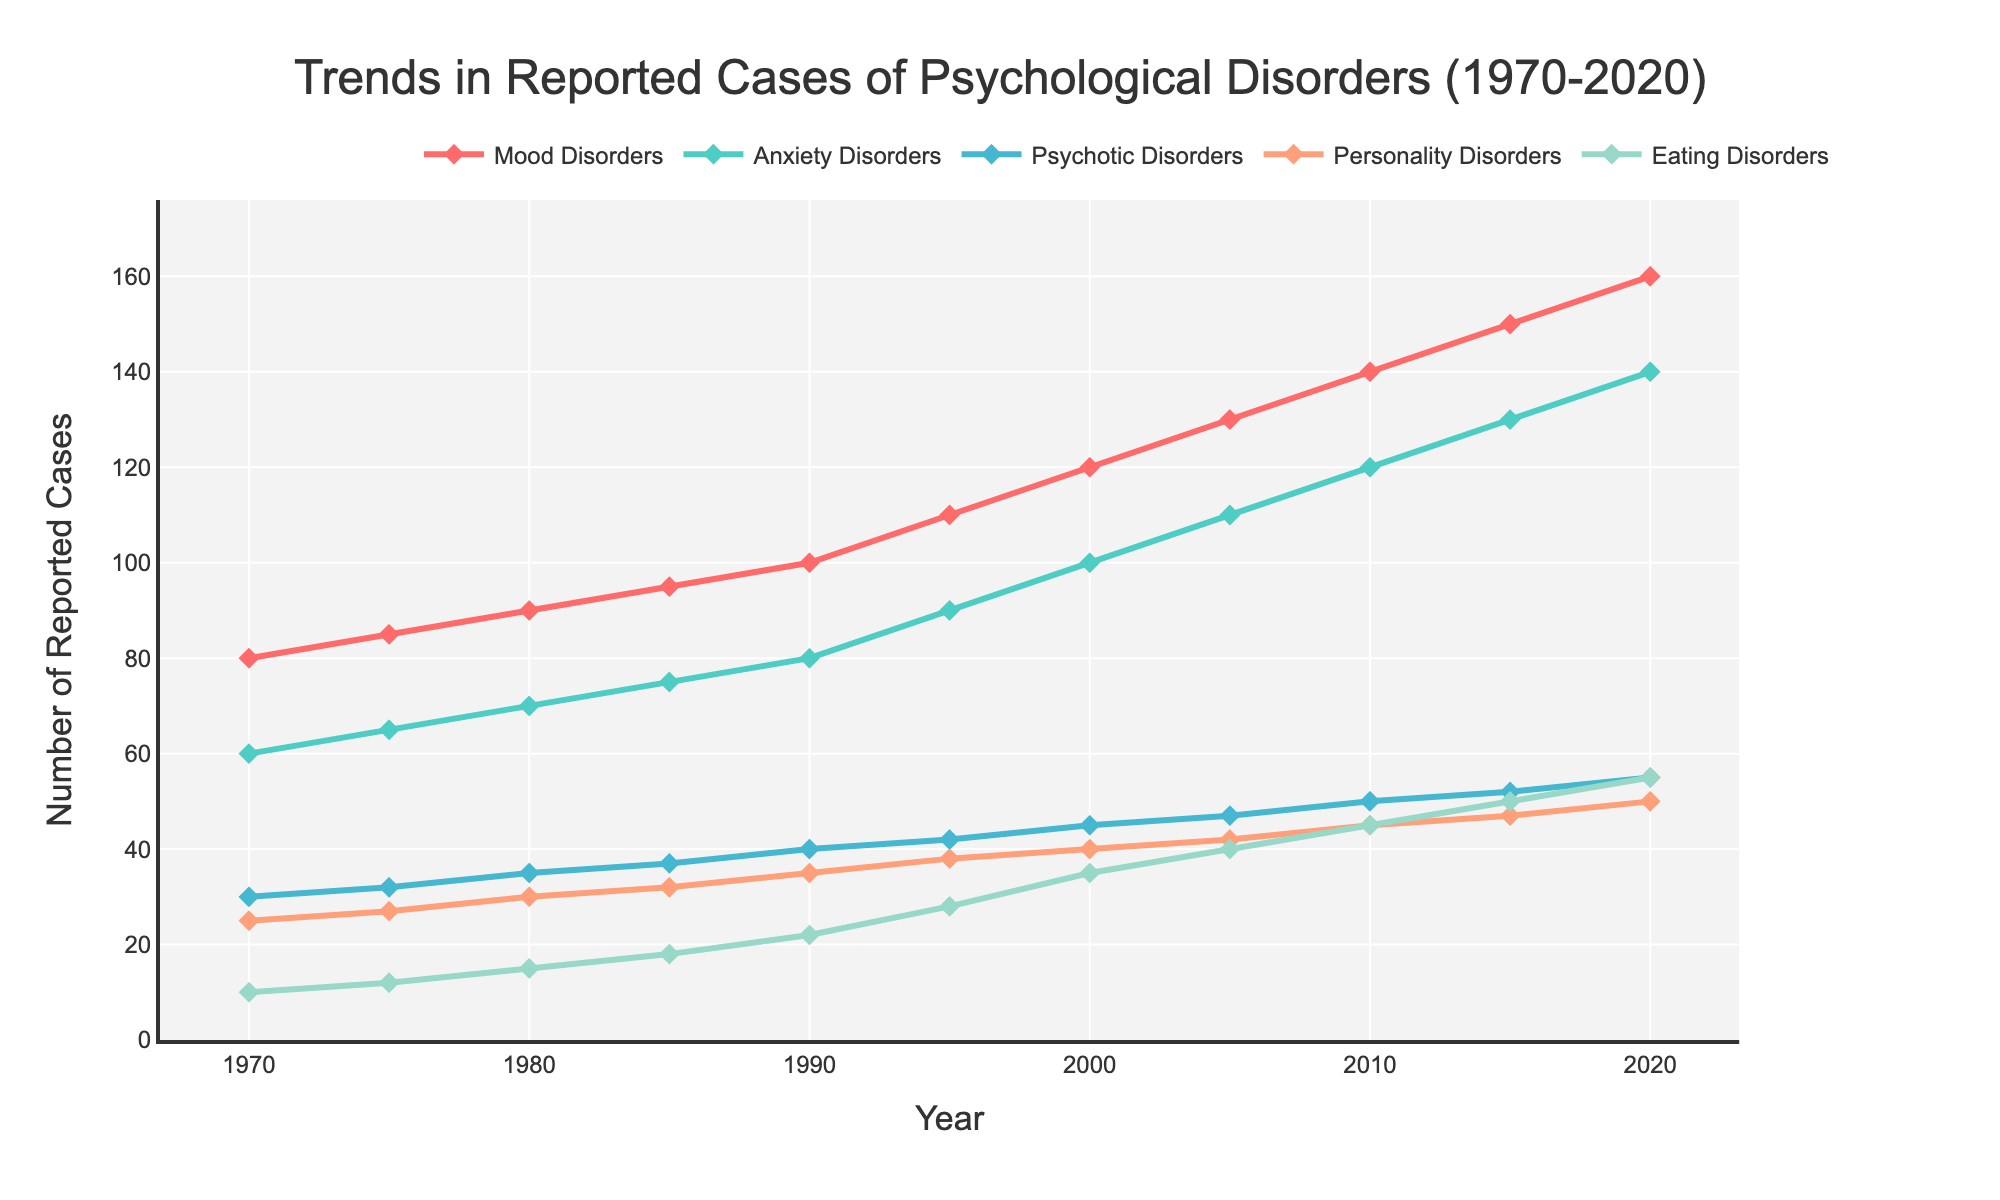What's the trend for Mood Disorders from 1970 to 2020? The line representing Mood Disorders shows a steady upward trend, increasing from 80 in 1970 to 160 in 2020. The increase appears to be consistent over the entire period.
Answer: A steady upward trend Which diagnostic group had the highest number of reported cases in 2020? In 2020, the Mood Disorders group had the highest number of reported cases with a value of 160. This can be observed as the green line reaches its highest point.
Answer: Mood Disorders Compare the growth of Anxiety Disorders and Eating Disorders from 1970 to 2020. Which grew faster? Anxiety Disorders increased from 60 to 140, while Eating Disorders increased from 10 to 55. The growth for Anxiety Disorders was 80, and for Eating Disorders, it was 45. Therefore, Anxiety Disorders grew faster.
Answer: Anxiety Disorders What was the difference in reported cases between Mood Disorders and Personality Disorders in 1990? In 1990, Mood Disorders had 100 cases and Personality Disorders had 35 cases. The difference is 100 - 35 = 65.
Answer: 65 Calculate the average number of reported cases for Psychotic Disorders from 1970 to 2020. The reported cases for each decade are: 30, 32, 35, 37, 40, 42, 45, 47, 50, 52, 55. The sum is 465, and there are 11 data points. The average is 465 / 11 = 42.27.
Answer: 42.27 Which diagnostic group shows the least growth over the 50-year period? To find this, we subtract the initial value from the final value for each group. Eating Disorders had the least growth, increasing only by 45 (from 10 in 1970 to 55 in 2020).
Answer: Eating Disorders How many more cases of Anxiety Disorders were reported in 2020 compared to 1980? In 1980, there were 70 cases of Anxiety Disorders and 140 in 2020. The difference is 140 - 70 = 70.
Answer: 70 What is the color representing Personality Disorders on the chart? The line representing Personality Disorders is in orange/pink color. By verifying the legend, it's easy to identify which color corresponds to each diagnostic group.
Answer: Orange/Pink Were Psychotic Disorders ever the group with the least number of reported cases in any given year? In all the years from 1970 to 2020, Psychotic Disorders always had more reported cases compared to Eating Disorders, which had the least number of cases each year.
Answer: No Which year saw Mood Disorders reaching 150 reported cases? Mood Disorders reached the 150 mark in the year 2015, as observed on the graph where the green line crosses the 150 mark.
Answer: 2015 